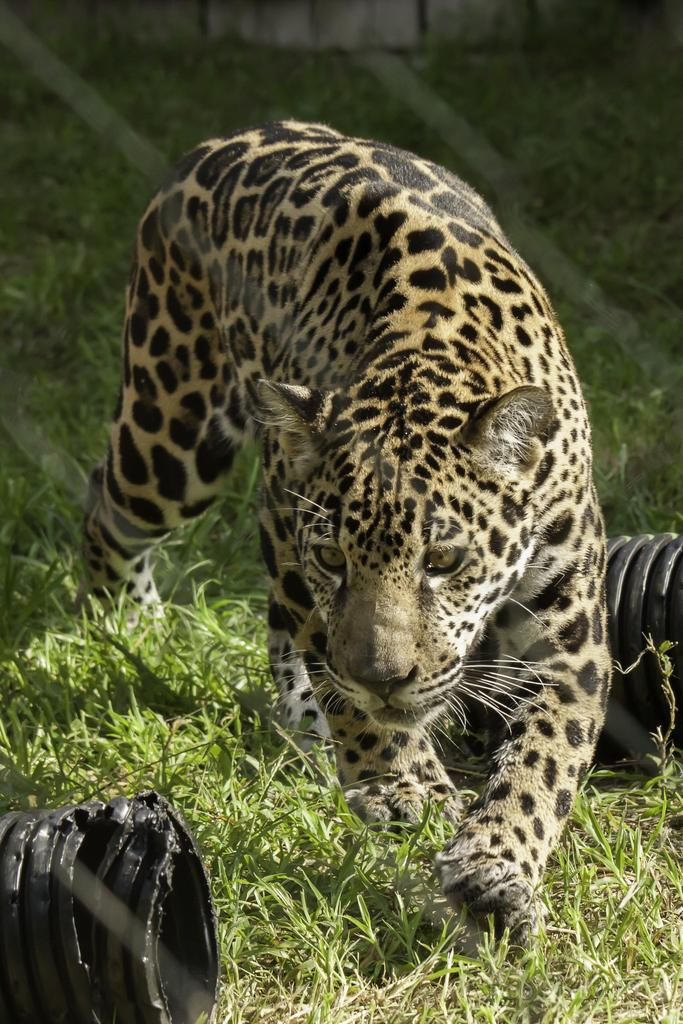What animal is in the image? There is a cheetah in the image. Where is the cheetah located? The cheetah is on the ground. What can be seen in the background of the image? There are objects in the background of the image. How many eggs are being cooked in the image? There are no eggs or cooking activity present in the image; it features a cheetah on the ground. What type of heat source is being used to cook the eggs in the image? There are no eggs or cooking activity present in the image, so it is not possible to determine what type of heat source might be used. 